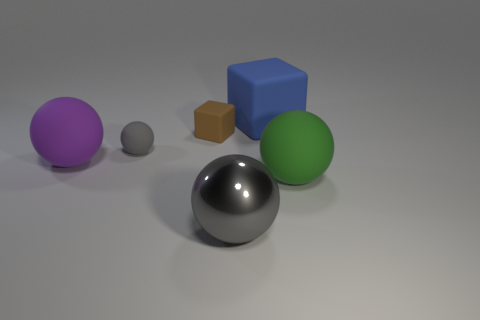There is a big sphere that is to the right of the big matte thing behind the big purple object; what color is it?
Provide a short and direct response. Green. There is a tiny cube that is the same material as the purple sphere; what is its color?
Keep it short and to the point. Brown. What number of small matte objects are the same color as the big rubber block?
Offer a very short reply. 0. How many objects are large gray things or cubes?
Provide a succinct answer. 3. What shape is the green thing that is the same size as the gray metallic sphere?
Make the answer very short. Sphere. What number of matte objects are both in front of the blue cube and behind the green object?
Provide a succinct answer. 3. What is the material of the sphere that is behind the large purple rubber thing?
Provide a short and direct response. Rubber. There is a purple ball that is the same material as the green thing; what is its size?
Offer a very short reply. Large. Is the size of the rubber object that is to the right of the large blue thing the same as the gray object behind the large purple matte thing?
Provide a short and direct response. No. There is a gray thing that is the same size as the blue thing; what is it made of?
Provide a short and direct response. Metal. 